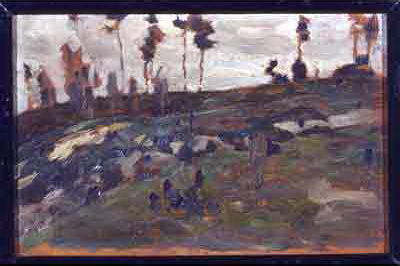What might the artist be trying to communicate through the landscape depicted here? The artist seems to be exploring themes of endurance and timelessness through the rugged, unyielding terrain depicted in the landscape. The sparse vegetation and resilient trees that dot the hillside, standing tall against the elements, may symbolize strength and persistence. This interpretation is further reinforced by the painting's rough, expressive strokes, which imbue the scene with a dynamic, yet enduring, energy. Thus, the landscape could be viewed as a metaphor for enduring challenges or changes over time. 